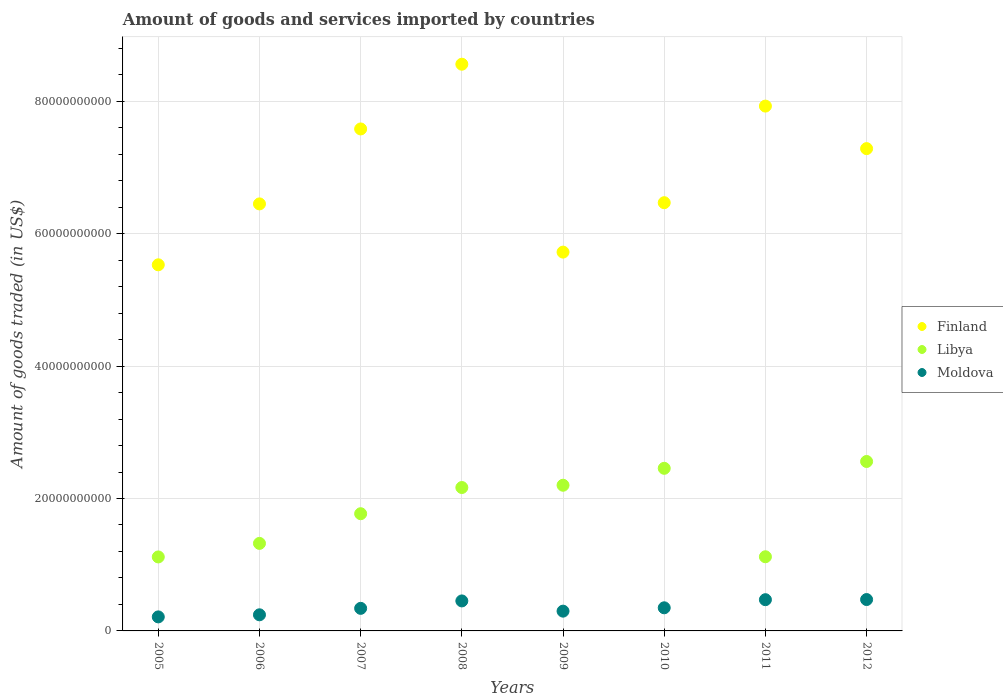How many different coloured dotlines are there?
Offer a terse response. 3. What is the total amount of goods and services imported in Libya in 2011?
Provide a succinct answer. 1.12e+1. Across all years, what is the maximum total amount of goods and services imported in Finland?
Provide a short and direct response. 8.56e+1. Across all years, what is the minimum total amount of goods and services imported in Moldova?
Your answer should be very brief. 2.12e+09. In which year was the total amount of goods and services imported in Libya maximum?
Give a very brief answer. 2012. What is the total total amount of goods and services imported in Finland in the graph?
Your response must be concise. 5.55e+11. What is the difference between the total amount of goods and services imported in Libya in 2005 and that in 2006?
Your answer should be compact. -2.04e+09. What is the difference between the total amount of goods and services imported in Finland in 2006 and the total amount of goods and services imported in Libya in 2005?
Ensure brevity in your answer.  5.33e+1. What is the average total amount of goods and services imported in Finland per year?
Offer a very short reply. 6.94e+1. In the year 2005, what is the difference between the total amount of goods and services imported in Libya and total amount of goods and services imported in Moldova?
Provide a short and direct response. 9.06e+09. What is the ratio of the total amount of goods and services imported in Finland in 2007 to that in 2009?
Provide a succinct answer. 1.33. Is the total amount of goods and services imported in Moldova in 2008 less than that in 2012?
Offer a terse response. Yes. What is the difference between the highest and the second highest total amount of goods and services imported in Libya?
Offer a very short reply. 1.03e+09. What is the difference between the highest and the lowest total amount of goods and services imported in Libya?
Provide a succinct answer. 1.44e+1. In how many years, is the total amount of goods and services imported in Moldova greater than the average total amount of goods and services imported in Moldova taken over all years?
Provide a succinct answer. 3. Is it the case that in every year, the sum of the total amount of goods and services imported in Libya and total amount of goods and services imported in Finland  is greater than the total amount of goods and services imported in Moldova?
Your answer should be compact. Yes. Does the total amount of goods and services imported in Libya monotonically increase over the years?
Give a very brief answer. No. Is the total amount of goods and services imported in Libya strictly greater than the total amount of goods and services imported in Finland over the years?
Keep it short and to the point. No. Is the total amount of goods and services imported in Libya strictly less than the total amount of goods and services imported in Moldova over the years?
Your answer should be compact. No. How many dotlines are there?
Give a very brief answer. 3. What is the difference between two consecutive major ticks on the Y-axis?
Make the answer very short. 2.00e+1. What is the title of the graph?
Ensure brevity in your answer.  Amount of goods and services imported by countries. Does "Kiribati" appear as one of the legend labels in the graph?
Ensure brevity in your answer.  No. What is the label or title of the X-axis?
Your response must be concise. Years. What is the label or title of the Y-axis?
Your response must be concise. Amount of goods traded (in US$). What is the Amount of goods traded (in US$) of Finland in 2005?
Ensure brevity in your answer.  5.53e+1. What is the Amount of goods traded (in US$) of Libya in 2005?
Provide a succinct answer. 1.12e+1. What is the Amount of goods traded (in US$) of Moldova in 2005?
Make the answer very short. 2.12e+09. What is the Amount of goods traded (in US$) of Finland in 2006?
Give a very brief answer. 6.45e+1. What is the Amount of goods traded (in US$) of Libya in 2006?
Your answer should be very brief. 1.32e+1. What is the Amount of goods traded (in US$) in Moldova in 2006?
Provide a short and direct response. 2.43e+09. What is the Amount of goods traded (in US$) of Finland in 2007?
Keep it short and to the point. 7.58e+1. What is the Amount of goods traded (in US$) of Libya in 2007?
Provide a short and direct response. 1.77e+1. What is the Amount of goods traded (in US$) of Moldova in 2007?
Make the answer very short. 3.41e+09. What is the Amount of goods traded (in US$) in Finland in 2008?
Ensure brevity in your answer.  8.56e+1. What is the Amount of goods traded (in US$) of Libya in 2008?
Your answer should be compact. 2.17e+1. What is the Amount of goods traded (in US$) in Moldova in 2008?
Your answer should be compact. 4.53e+09. What is the Amount of goods traded (in US$) of Finland in 2009?
Keep it short and to the point. 5.72e+1. What is the Amount of goods traded (in US$) of Libya in 2009?
Offer a very short reply. 2.20e+1. What is the Amount of goods traded (in US$) of Moldova in 2009?
Offer a very short reply. 2.99e+09. What is the Amount of goods traded (in US$) in Finland in 2010?
Your response must be concise. 6.47e+1. What is the Amount of goods traded (in US$) in Libya in 2010?
Provide a short and direct response. 2.46e+1. What is the Amount of goods traded (in US$) of Moldova in 2010?
Your answer should be very brief. 3.49e+09. What is the Amount of goods traded (in US$) of Finland in 2011?
Offer a terse response. 7.93e+1. What is the Amount of goods traded (in US$) in Libya in 2011?
Keep it short and to the point. 1.12e+1. What is the Amount of goods traded (in US$) in Moldova in 2011?
Your response must be concise. 4.72e+09. What is the Amount of goods traded (in US$) in Finland in 2012?
Give a very brief answer. 7.28e+1. What is the Amount of goods traded (in US$) of Libya in 2012?
Make the answer very short. 2.56e+1. What is the Amount of goods traded (in US$) in Moldova in 2012?
Offer a terse response. 4.74e+09. Across all years, what is the maximum Amount of goods traded (in US$) of Finland?
Keep it short and to the point. 8.56e+1. Across all years, what is the maximum Amount of goods traded (in US$) in Libya?
Offer a very short reply. 2.56e+1. Across all years, what is the maximum Amount of goods traded (in US$) in Moldova?
Provide a succinct answer. 4.74e+09. Across all years, what is the minimum Amount of goods traded (in US$) in Finland?
Provide a succinct answer. 5.53e+1. Across all years, what is the minimum Amount of goods traded (in US$) in Libya?
Ensure brevity in your answer.  1.12e+1. Across all years, what is the minimum Amount of goods traded (in US$) of Moldova?
Offer a very short reply. 2.12e+09. What is the total Amount of goods traded (in US$) of Finland in the graph?
Your answer should be compact. 5.55e+11. What is the total Amount of goods traded (in US$) in Libya in the graph?
Make the answer very short. 1.47e+11. What is the total Amount of goods traded (in US$) in Moldova in the graph?
Your answer should be compact. 2.84e+1. What is the difference between the Amount of goods traded (in US$) of Finland in 2005 and that in 2006?
Your response must be concise. -9.20e+09. What is the difference between the Amount of goods traded (in US$) in Libya in 2005 and that in 2006?
Your answer should be very brief. -2.04e+09. What is the difference between the Amount of goods traded (in US$) in Moldova in 2005 and that in 2006?
Ensure brevity in your answer.  -3.15e+08. What is the difference between the Amount of goods traded (in US$) of Finland in 2005 and that in 2007?
Your response must be concise. -2.05e+1. What is the difference between the Amount of goods traded (in US$) in Libya in 2005 and that in 2007?
Make the answer very short. -6.53e+09. What is the difference between the Amount of goods traded (in US$) in Moldova in 2005 and that in 2007?
Offer a very short reply. -1.29e+09. What is the difference between the Amount of goods traded (in US$) in Finland in 2005 and that in 2008?
Offer a terse response. -3.03e+1. What is the difference between the Amount of goods traded (in US$) of Libya in 2005 and that in 2008?
Your answer should be compact. -1.05e+1. What is the difference between the Amount of goods traded (in US$) of Moldova in 2005 and that in 2008?
Your answer should be very brief. -2.41e+09. What is the difference between the Amount of goods traded (in US$) in Finland in 2005 and that in 2009?
Ensure brevity in your answer.  -1.92e+09. What is the difference between the Amount of goods traded (in US$) in Libya in 2005 and that in 2009?
Provide a succinct answer. -1.08e+1. What is the difference between the Amount of goods traded (in US$) of Moldova in 2005 and that in 2009?
Offer a terse response. -8.68e+08. What is the difference between the Amount of goods traded (in US$) in Finland in 2005 and that in 2010?
Your answer should be compact. -9.38e+09. What is the difference between the Amount of goods traded (in US$) in Libya in 2005 and that in 2010?
Ensure brevity in your answer.  -1.34e+1. What is the difference between the Amount of goods traded (in US$) in Moldova in 2005 and that in 2010?
Give a very brief answer. -1.37e+09. What is the difference between the Amount of goods traded (in US$) of Finland in 2005 and that in 2011?
Your response must be concise. -2.40e+1. What is the difference between the Amount of goods traded (in US$) of Libya in 2005 and that in 2011?
Your answer should be compact. -2.60e+07. What is the difference between the Amount of goods traded (in US$) in Moldova in 2005 and that in 2011?
Give a very brief answer. -2.60e+09. What is the difference between the Amount of goods traded (in US$) in Finland in 2005 and that in 2012?
Your answer should be very brief. -1.75e+1. What is the difference between the Amount of goods traded (in US$) in Libya in 2005 and that in 2012?
Provide a succinct answer. -1.44e+1. What is the difference between the Amount of goods traded (in US$) in Moldova in 2005 and that in 2012?
Keep it short and to the point. -2.62e+09. What is the difference between the Amount of goods traded (in US$) in Finland in 2006 and that in 2007?
Your answer should be compact. -1.13e+1. What is the difference between the Amount of goods traded (in US$) in Libya in 2006 and that in 2007?
Provide a succinct answer. -4.48e+09. What is the difference between the Amount of goods traded (in US$) in Moldova in 2006 and that in 2007?
Ensure brevity in your answer.  -9.75e+08. What is the difference between the Amount of goods traded (in US$) in Finland in 2006 and that in 2008?
Give a very brief answer. -2.11e+1. What is the difference between the Amount of goods traded (in US$) of Libya in 2006 and that in 2008?
Your answer should be compact. -8.44e+09. What is the difference between the Amount of goods traded (in US$) in Moldova in 2006 and that in 2008?
Keep it short and to the point. -2.10e+09. What is the difference between the Amount of goods traded (in US$) in Finland in 2006 and that in 2009?
Provide a short and direct response. 7.28e+09. What is the difference between the Amount of goods traded (in US$) in Libya in 2006 and that in 2009?
Offer a very short reply. -8.78e+09. What is the difference between the Amount of goods traded (in US$) in Moldova in 2006 and that in 2009?
Give a very brief answer. -5.53e+08. What is the difference between the Amount of goods traded (in US$) of Finland in 2006 and that in 2010?
Keep it short and to the point. -1.81e+08. What is the difference between the Amount of goods traded (in US$) in Libya in 2006 and that in 2010?
Your answer should be very brief. -1.13e+1. What is the difference between the Amount of goods traded (in US$) of Moldova in 2006 and that in 2010?
Your response must be concise. -1.06e+09. What is the difference between the Amount of goods traded (in US$) of Finland in 2006 and that in 2011?
Give a very brief answer. -1.48e+1. What is the difference between the Amount of goods traded (in US$) of Libya in 2006 and that in 2011?
Ensure brevity in your answer.  2.02e+09. What is the difference between the Amount of goods traded (in US$) in Moldova in 2006 and that in 2011?
Offer a terse response. -2.28e+09. What is the difference between the Amount of goods traded (in US$) in Finland in 2006 and that in 2012?
Your answer should be compact. -8.35e+09. What is the difference between the Amount of goods traded (in US$) in Libya in 2006 and that in 2012?
Keep it short and to the point. -1.24e+1. What is the difference between the Amount of goods traded (in US$) of Moldova in 2006 and that in 2012?
Provide a succinct answer. -2.30e+09. What is the difference between the Amount of goods traded (in US$) in Finland in 2007 and that in 2008?
Your answer should be compact. -9.78e+09. What is the difference between the Amount of goods traded (in US$) in Libya in 2007 and that in 2008?
Your response must be concise. -3.96e+09. What is the difference between the Amount of goods traded (in US$) in Moldova in 2007 and that in 2008?
Your response must be concise. -1.12e+09. What is the difference between the Amount of goods traded (in US$) in Finland in 2007 and that in 2009?
Keep it short and to the point. 1.86e+1. What is the difference between the Amount of goods traded (in US$) of Libya in 2007 and that in 2009?
Provide a succinct answer. -4.30e+09. What is the difference between the Amount of goods traded (in US$) in Moldova in 2007 and that in 2009?
Make the answer very short. 4.22e+08. What is the difference between the Amount of goods traded (in US$) in Finland in 2007 and that in 2010?
Offer a terse response. 1.11e+1. What is the difference between the Amount of goods traded (in US$) of Libya in 2007 and that in 2010?
Your response must be concise. -6.86e+09. What is the difference between the Amount of goods traded (in US$) of Moldova in 2007 and that in 2010?
Make the answer very short. -8.27e+07. What is the difference between the Amount of goods traded (in US$) in Finland in 2007 and that in 2011?
Offer a terse response. -3.45e+09. What is the difference between the Amount of goods traded (in US$) in Libya in 2007 and that in 2011?
Your answer should be very brief. 6.50e+09. What is the difference between the Amount of goods traded (in US$) in Moldova in 2007 and that in 2011?
Offer a terse response. -1.31e+09. What is the difference between the Amount of goods traded (in US$) in Finland in 2007 and that in 2012?
Keep it short and to the point. 2.97e+09. What is the difference between the Amount of goods traded (in US$) of Libya in 2007 and that in 2012?
Your response must be concise. -7.89e+09. What is the difference between the Amount of goods traded (in US$) in Moldova in 2007 and that in 2012?
Offer a terse response. -1.33e+09. What is the difference between the Amount of goods traded (in US$) of Finland in 2008 and that in 2009?
Make the answer very short. 2.84e+1. What is the difference between the Amount of goods traded (in US$) of Libya in 2008 and that in 2009?
Provide a succinct answer. -3.44e+08. What is the difference between the Amount of goods traded (in US$) in Moldova in 2008 and that in 2009?
Keep it short and to the point. 1.54e+09. What is the difference between the Amount of goods traded (in US$) of Finland in 2008 and that in 2010?
Provide a short and direct response. 2.09e+1. What is the difference between the Amount of goods traded (in US$) in Libya in 2008 and that in 2010?
Your answer should be compact. -2.90e+09. What is the difference between the Amount of goods traded (in US$) of Moldova in 2008 and that in 2010?
Keep it short and to the point. 1.04e+09. What is the difference between the Amount of goods traded (in US$) of Finland in 2008 and that in 2011?
Your answer should be compact. 6.33e+09. What is the difference between the Amount of goods traded (in US$) of Libya in 2008 and that in 2011?
Offer a terse response. 1.05e+1. What is the difference between the Amount of goods traded (in US$) in Moldova in 2008 and that in 2011?
Keep it short and to the point. -1.86e+08. What is the difference between the Amount of goods traded (in US$) in Finland in 2008 and that in 2012?
Keep it short and to the point. 1.27e+1. What is the difference between the Amount of goods traded (in US$) of Libya in 2008 and that in 2012?
Your answer should be very brief. -3.93e+09. What is the difference between the Amount of goods traded (in US$) in Moldova in 2008 and that in 2012?
Your response must be concise. -2.09e+08. What is the difference between the Amount of goods traded (in US$) of Finland in 2009 and that in 2010?
Offer a very short reply. -7.46e+09. What is the difference between the Amount of goods traded (in US$) of Libya in 2009 and that in 2010?
Provide a succinct answer. -2.56e+09. What is the difference between the Amount of goods traded (in US$) in Moldova in 2009 and that in 2010?
Provide a short and direct response. -5.05e+08. What is the difference between the Amount of goods traded (in US$) in Finland in 2009 and that in 2011?
Give a very brief answer. -2.21e+1. What is the difference between the Amount of goods traded (in US$) of Libya in 2009 and that in 2011?
Provide a short and direct response. 1.08e+1. What is the difference between the Amount of goods traded (in US$) of Moldova in 2009 and that in 2011?
Your answer should be compact. -1.73e+09. What is the difference between the Amount of goods traded (in US$) of Finland in 2009 and that in 2012?
Your answer should be very brief. -1.56e+1. What is the difference between the Amount of goods traded (in US$) in Libya in 2009 and that in 2012?
Make the answer very short. -3.59e+09. What is the difference between the Amount of goods traded (in US$) in Moldova in 2009 and that in 2012?
Make the answer very short. -1.75e+09. What is the difference between the Amount of goods traded (in US$) of Finland in 2010 and that in 2011?
Offer a very short reply. -1.46e+1. What is the difference between the Amount of goods traded (in US$) in Libya in 2010 and that in 2011?
Offer a very short reply. 1.34e+1. What is the difference between the Amount of goods traded (in US$) in Moldova in 2010 and that in 2011?
Your response must be concise. -1.22e+09. What is the difference between the Amount of goods traded (in US$) of Finland in 2010 and that in 2012?
Give a very brief answer. -8.17e+09. What is the difference between the Amount of goods traded (in US$) of Libya in 2010 and that in 2012?
Give a very brief answer. -1.03e+09. What is the difference between the Amount of goods traded (in US$) in Moldova in 2010 and that in 2012?
Keep it short and to the point. -1.25e+09. What is the difference between the Amount of goods traded (in US$) of Finland in 2011 and that in 2012?
Make the answer very short. 6.42e+09. What is the difference between the Amount of goods traded (in US$) in Libya in 2011 and that in 2012?
Offer a very short reply. -1.44e+1. What is the difference between the Amount of goods traded (in US$) in Moldova in 2011 and that in 2012?
Ensure brevity in your answer.  -2.27e+07. What is the difference between the Amount of goods traded (in US$) in Finland in 2005 and the Amount of goods traded (in US$) in Libya in 2006?
Keep it short and to the point. 4.21e+1. What is the difference between the Amount of goods traded (in US$) of Finland in 2005 and the Amount of goods traded (in US$) of Moldova in 2006?
Keep it short and to the point. 5.29e+1. What is the difference between the Amount of goods traded (in US$) of Libya in 2005 and the Amount of goods traded (in US$) of Moldova in 2006?
Your answer should be compact. 8.74e+09. What is the difference between the Amount of goods traded (in US$) in Finland in 2005 and the Amount of goods traded (in US$) in Libya in 2007?
Give a very brief answer. 3.76e+1. What is the difference between the Amount of goods traded (in US$) of Finland in 2005 and the Amount of goods traded (in US$) of Moldova in 2007?
Provide a succinct answer. 5.19e+1. What is the difference between the Amount of goods traded (in US$) in Libya in 2005 and the Amount of goods traded (in US$) in Moldova in 2007?
Offer a very short reply. 7.77e+09. What is the difference between the Amount of goods traded (in US$) of Finland in 2005 and the Amount of goods traded (in US$) of Libya in 2008?
Your answer should be compact. 3.36e+1. What is the difference between the Amount of goods traded (in US$) in Finland in 2005 and the Amount of goods traded (in US$) in Moldova in 2008?
Offer a very short reply. 5.08e+1. What is the difference between the Amount of goods traded (in US$) in Libya in 2005 and the Amount of goods traded (in US$) in Moldova in 2008?
Give a very brief answer. 6.64e+09. What is the difference between the Amount of goods traded (in US$) in Finland in 2005 and the Amount of goods traded (in US$) in Libya in 2009?
Offer a terse response. 3.33e+1. What is the difference between the Amount of goods traded (in US$) in Finland in 2005 and the Amount of goods traded (in US$) in Moldova in 2009?
Your response must be concise. 5.23e+1. What is the difference between the Amount of goods traded (in US$) in Libya in 2005 and the Amount of goods traded (in US$) in Moldova in 2009?
Your answer should be compact. 8.19e+09. What is the difference between the Amount of goods traded (in US$) in Finland in 2005 and the Amount of goods traded (in US$) in Libya in 2010?
Your answer should be compact. 3.07e+1. What is the difference between the Amount of goods traded (in US$) in Finland in 2005 and the Amount of goods traded (in US$) in Moldova in 2010?
Your response must be concise. 5.18e+1. What is the difference between the Amount of goods traded (in US$) of Libya in 2005 and the Amount of goods traded (in US$) of Moldova in 2010?
Give a very brief answer. 7.68e+09. What is the difference between the Amount of goods traded (in US$) of Finland in 2005 and the Amount of goods traded (in US$) of Libya in 2011?
Your response must be concise. 4.41e+1. What is the difference between the Amount of goods traded (in US$) in Finland in 2005 and the Amount of goods traded (in US$) in Moldova in 2011?
Offer a terse response. 5.06e+1. What is the difference between the Amount of goods traded (in US$) of Libya in 2005 and the Amount of goods traded (in US$) of Moldova in 2011?
Your answer should be compact. 6.46e+09. What is the difference between the Amount of goods traded (in US$) of Finland in 2005 and the Amount of goods traded (in US$) of Libya in 2012?
Offer a very short reply. 2.97e+1. What is the difference between the Amount of goods traded (in US$) in Finland in 2005 and the Amount of goods traded (in US$) in Moldova in 2012?
Keep it short and to the point. 5.06e+1. What is the difference between the Amount of goods traded (in US$) of Libya in 2005 and the Amount of goods traded (in US$) of Moldova in 2012?
Offer a terse response. 6.44e+09. What is the difference between the Amount of goods traded (in US$) of Finland in 2006 and the Amount of goods traded (in US$) of Libya in 2007?
Offer a very short reply. 4.68e+1. What is the difference between the Amount of goods traded (in US$) of Finland in 2006 and the Amount of goods traded (in US$) of Moldova in 2007?
Make the answer very short. 6.11e+1. What is the difference between the Amount of goods traded (in US$) of Libya in 2006 and the Amount of goods traded (in US$) of Moldova in 2007?
Ensure brevity in your answer.  9.81e+09. What is the difference between the Amount of goods traded (in US$) in Finland in 2006 and the Amount of goods traded (in US$) in Libya in 2008?
Offer a terse response. 4.28e+1. What is the difference between the Amount of goods traded (in US$) in Finland in 2006 and the Amount of goods traded (in US$) in Moldova in 2008?
Provide a succinct answer. 6.00e+1. What is the difference between the Amount of goods traded (in US$) in Libya in 2006 and the Amount of goods traded (in US$) in Moldova in 2008?
Provide a short and direct response. 8.69e+09. What is the difference between the Amount of goods traded (in US$) of Finland in 2006 and the Amount of goods traded (in US$) of Libya in 2009?
Offer a very short reply. 4.25e+1. What is the difference between the Amount of goods traded (in US$) in Finland in 2006 and the Amount of goods traded (in US$) in Moldova in 2009?
Your answer should be compact. 6.15e+1. What is the difference between the Amount of goods traded (in US$) of Libya in 2006 and the Amount of goods traded (in US$) of Moldova in 2009?
Make the answer very short. 1.02e+1. What is the difference between the Amount of goods traded (in US$) in Finland in 2006 and the Amount of goods traded (in US$) in Libya in 2010?
Your response must be concise. 3.99e+1. What is the difference between the Amount of goods traded (in US$) in Finland in 2006 and the Amount of goods traded (in US$) in Moldova in 2010?
Your response must be concise. 6.10e+1. What is the difference between the Amount of goods traded (in US$) in Libya in 2006 and the Amount of goods traded (in US$) in Moldova in 2010?
Keep it short and to the point. 9.73e+09. What is the difference between the Amount of goods traded (in US$) in Finland in 2006 and the Amount of goods traded (in US$) in Libya in 2011?
Make the answer very short. 5.33e+1. What is the difference between the Amount of goods traded (in US$) in Finland in 2006 and the Amount of goods traded (in US$) in Moldova in 2011?
Keep it short and to the point. 5.98e+1. What is the difference between the Amount of goods traded (in US$) of Libya in 2006 and the Amount of goods traded (in US$) of Moldova in 2011?
Provide a succinct answer. 8.50e+09. What is the difference between the Amount of goods traded (in US$) of Finland in 2006 and the Amount of goods traded (in US$) of Libya in 2012?
Keep it short and to the point. 3.89e+1. What is the difference between the Amount of goods traded (in US$) in Finland in 2006 and the Amount of goods traded (in US$) in Moldova in 2012?
Make the answer very short. 5.98e+1. What is the difference between the Amount of goods traded (in US$) of Libya in 2006 and the Amount of goods traded (in US$) of Moldova in 2012?
Provide a succinct answer. 8.48e+09. What is the difference between the Amount of goods traded (in US$) in Finland in 2007 and the Amount of goods traded (in US$) in Libya in 2008?
Ensure brevity in your answer.  5.42e+1. What is the difference between the Amount of goods traded (in US$) of Finland in 2007 and the Amount of goods traded (in US$) of Moldova in 2008?
Your answer should be very brief. 7.13e+1. What is the difference between the Amount of goods traded (in US$) of Libya in 2007 and the Amount of goods traded (in US$) of Moldova in 2008?
Your answer should be very brief. 1.32e+1. What is the difference between the Amount of goods traded (in US$) of Finland in 2007 and the Amount of goods traded (in US$) of Libya in 2009?
Provide a succinct answer. 5.38e+1. What is the difference between the Amount of goods traded (in US$) in Finland in 2007 and the Amount of goods traded (in US$) in Moldova in 2009?
Ensure brevity in your answer.  7.28e+1. What is the difference between the Amount of goods traded (in US$) of Libya in 2007 and the Amount of goods traded (in US$) of Moldova in 2009?
Ensure brevity in your answer.  1.47e+1. What is the difference between the Amount of goods traded (in US$) of Finland in 2007 and the Amount of goods traded (in US$) of Libya in 2010?
Make the answer very short. 5.13e+1. What is the difference between the Amount of goods traded (in US$) in Finland in 2007 and the Amount of goods traded (in US$) in Moldova in 2010?
Your answer should be compact. 7.23e+1. What is the difference between the Amount of goods traded (in US$) in Libya in 2007 and the Amount of goods traded (in US$) in Moldova in 2010?
Provide a short and direct response. 1.42e+1. What is the difference between the Amount of goods traded (in US$) of Finland in 2007 and the Amount of goods traded (in US$) of Libya in 2011?
Your answer should be very brief. 6.46e+1. What is the difference between the Amount of goods traded (in US$) of Finland in 2007 and the Amount of goods traded (in US$) of Moldova in 2011?
Give a very brief answer. 7.11e+1. What is the difference between the Amount of goods traded (in US$) of Libya in 2007 and the Amount of goods traded (in US$) of Moldova in 2011?
Keep it short and to the point. 1.30e+1. What is the difference between the Amount of goods traded (in US$) of Finland in 2007 and the Amount of goods traded (in US$) of Libya in 2012?
Provide a succinct answer. 5.02e+1. What is the difference between the Amount of goods traded (in US$) in Finland in 2007 and the Amount of goods traded (in US$) in Moldova in 2012?
Your answer should be very brief. 7.11e+1. What is the difference between the Amount of goods traded (in US$) of Libya in 2007 and the Amount of goods traded (in US$) of Moldova in 2012?
Provide a short and direct response. 1.30e+1. What is the difference between the Amount of goods traded (in US$) in Finland in 2008 and the Amount of goods traded (in US$) in Libya in 2009?
Give a very brief answer. 6.36e+1. What is the difference between the Amount of goods traded (in US$) of Finland in 2008 and the Amount of goods traded (in US$) of Moldova in 2009?
Keep it short and to the point. 8.26e+1. What is the difference between the Amount of goods traded (in US$) in Libya in 2008 and the Amount of goods traded (in US$) in Moldova in 2009?
Provide a succinct answer. 1.87e+1. What is the difference between the Amount of goods traded (in US$) in Finland in 2008 and the Amount of goods traded (in US$) in Libya in 2010?
Offer a very short reply. 6.10e+1. What is the difference between the Amount of goods traded (in US$) of Finland in 2008 and the Amount of goods traded (in US$) of Moldova in 2010?
Offer a very short reply. 8.21e+1. What is the difference between the Amount of goods traded (in US$) in Libya in 2008 and the Amount of goods traded (in US$) in Moldova in 2010?
Make the answer very short. 1.82e+1. What is the difference between the Amount of goods traded (in US$) in Finland in 2008 and the Amount of goods traded (in US$) in Libya in 2011?
Your answer should be very brief. 7.44e+1. What is the difference between the Amount of goods traded (in US$) in Finland in 2008 and the Amount of goods traded (in US$) in Moldova in 2011?
Give a very brief answer. 8.09e+1. What is the difference between the Amount of goods traded (in US$) in Libya in 2008 and the Amount of goods traded (in US$) in Moldova in 2011?
Make the answer very short. 1.69e+1. What is the difference between the Amount of goods traded (in US$) of Finland in 2008 and the Amount of goods traded (in US$) of Libya in 2012?
Make the answer very short. 6.00e+1. What is the difference between the Amount of goods traded (in US$) in Finland in 2008 and the Amount of goods traded (in US$) in Moldova in 2012?
Make the answer very short. 8.09e+1. What is the difference between the Amount of goods traded (in US$) in Libya in 2008 and the Amount of goods traded (in US$) in Moldova in 2012?
Your answer should be compact. 1.69e+1. What is the difference between the Amount of goods traded (in US$) of Finland in 2009 and the Amount of goods traded (in US$) of Libya in 2010?
Your response must be concise. 3.27e+1. What is the difference between the Amount of goods traded (in US$) in Finland in 2009 and the Amount of goods traded (in US$) in Moldova in 2010?
Provide a succinct answer. 5.37e+1. What is the difference between the Amount of goods traded (in US$) of Libya in 2009 and the Amount of goods traded (in US$) of Moldova in 2010?
Your answer should be very brief. 1.85e+1. What is the difference between the Amount of goods traded (in US$) of Finland in 2009 and the Amount of goods traded (in US$) of Libya in 2011?
Make the answer very short. 4.60e+1. What is the difference between the Amount of goods traded (in US$) of Finland in 2009 and the Amount of goods traded (in US$) of Moldova in 2011?
Offer a terse response. 5.25e+1. What is the difference between the Amount of goods traded (in US$) in Libya in 2009 and the Amount of goods traded (in US$) in Moldova in 2011?
Give a very brief answer. 1.73e+1. What is the difference between the Amount of goods traded (in US$) of Finland in 2009 and the Amount of goods traded (in US$) of Libya in 2012?
Provide a short and direct response. 3.16e+1. What is the difference between the Amount of goods traded (in US$) of Finland in 2009 and the Amount of goods traded (in US$) of Moldova in 2012?
Provide a short and direct response. 5.25e+1. What is the difference between the Amount of goods traded (in US$) of Libya in 2009 and the Amount of goods traded (in US$) of Moldova in 2012?
Offer a very short reply. 1.73e+1. What is the difference between the Amount of goods traded (in US$) of Finland in 2010 and the Amount of goods traded (in US$) of Libya in 2011?
Provide a short and direct response. 5.35e+1. What is the difference between the Amount of goods traded (in US$) of Finland in 2010 and the Amount of goods traded (in US$) of Moldova in 2011?
Your response must be concise. 6.00e+1. What is the difference between the Amount of goods traded (in US$) in Libya in 2010 and the Amount of goods traded (in US$) in Moldova in 2011?
Your response must be concise. 1.98e+1. What is the difference between the Amount of goods traded (in US$) in Finland in 2010 and the Amount of goods traded (in US$) in Libya in 2012?
Your response must be concise. 3.91e+1. What is the difference between the Amount of goods traded (in US$) of Finland in 2010 and the Amount of goods traded (in US$) of Moldova in 2012?
Offer a very short reply. 5.99e+1. What is the difference between the Amount of goods traded (in US$) of Libya in 2010 and the Amount of goods traded (in US$) of Moldova in 2012?
Offer a very short reply. 1.98e+1. What is the difference between the Amount of goods traded (in US$) in Finland in 2011 and the Amount of goods traded (in US$) in Libya in 2012?
Your response must be concise. 5.37e+1. What is the difference between the Amount of goods traded (in US$) of Finland in 2011 and the Amount of goods traded (in US$) of Moldova in 2012?
Keep it short and to the point. 7.45e+1. What is the difference between the Amount of goods traded (in US$) in Libya in 2011 and the Amount of goods traded (in US$) in Moldova in 2012?
Keep it short and to the point. 6.46e+09. What is the average Amount of goods traded (in US$) of Finland per year?
Make the answer very short. 6.94e+1. What is the average Amount of goods traded (in US$) of Libya per year?
Keep it short and to the point. 1.84e+1. What is the average Amount of goods traded (in US$) of Moldova per year?
Offer a very short reply. 3.55e+09. In the year 2005, what is the difference between the Amount of goods traded (in US$) of Finland and Amount of goods traded (in US$) of Libya?
Offer a very short reply. 4.41e+1. In the year 2005, what is the difference between the Amount of goods traded (in US$) of Finland and Amount of goods traded (in US$) of Moldova?
Give a very brief answer. 5.32e+1. In the year 2005, what is the difference between the Amount of goods traded (in US$) of Libya and Amount of goods traded (in US$) of Moldova?
Offer a very short reply. 9.06e+09. In the year 2006, what is the difference between the Amount of goods traded (in US$) in Finland and Amount of goods traded (in US$) in Libya?
Make the answer very short. 5.13e+1. In the year 2006, what is the difference between the Amount of goods traded (in US$) in Finland and Amount of goods traded (in US$) in Moldova?
Make the answer very short. 6.21e+1. In the year 2006, what is the difference between the Amount of goods traded (in US$) in Libya and Amount of goods traded (in US$) in Moldova?
Provide a succinct answer. 1.08e+1. In the year 2007, what is the difference between the Amount of goods traded (in US$) of Finland and Amount of goods traded (in US$) of Libya?
Your answer should be compact. 5.81e+1. In the year 2007, what is the difference between the Amount of goods traded (in US$) in Finland and Amount of goods traded (in US$) in Moldova?
Your answer should be compact. 7.24e+1. In the year 2007, what is the difference between the Amount of goods traded (in US$) in Libya and Amount of goods traded (in US$) in Moldova?
Give a very brief answer. 1.43e+1. In the year 2008, what is the difference between the Amount of goods traded (in US$) in Finland and Amount of goods traded (in US$) in Libya?
Provide a short and direct response. 6.39e+1. In the year 2008, what is the difference between the Amount of goods traded (in US$) of Finland and Amount of goods traded (in US$) of Moldova?
Provide a short and direct response. 8.11e+1. In the year 2008, what is the difference between the Amount of goods traded (in US$) of Libya and Amount of goods traded (in US$) of Moldova?
Make the answer very short. 1.71e+1. In the year 2009, what is the difference between the Amount of goods traded (in US$) in Finland and Amount of goods traded (in US$) in Libya?
Ensure brevity in your answer.  3.52e+1. In the year 2009, what is the difference between the Amount of goods traded (in US$) of Finland and Amount of goods traded (in US$) of Moldova?
Keep it short and to the point. 5.42e+1. In the year 2009, what is the difference between the Amount of goods traded (in US$) of Libya and Amount of goods traded (in US$) of Moldova?
Offer a terse response. 1.90e+1. In the year 2010, what is the difference between the Amount of goods traded (in US$) of Finland and Amount of goods traded (in US$) of Libya?
Make the answer very short. 4.01e+1. In the year 2010, what is the difference between the Amount of goods traded (in US$) in Finland and Amount of goods traded (in US$) in Moldova?
Provide a short and direct response. 6.12e+1. In the year 2010, what is the difference between the Amount of goods traded (in US$) of Libya and Amount of goods traded (in US$) of Moldova?
Your answer should be compact. 2.11e+1. In the year 2011, what is the difference between the Amount of goods traded (in US$) in Finland and Amount of goods traded (in US$) in Libya?
Provide a short and direct response. 6.81e+1. In the year 2011, what is the difference between the Amount of goods traded (in US$) of Finland and Amount of goods traded (in US$) of Moldova?
Your answer should be compact. 7.45e+1. In the year 2011, what is the difference between the Amount of goods traded (in US$) in Libya and Amount of goods traded (in US$) in Moldova?
Offer a very short reply. 6.48e+09. In the year 2012, what is the difference between the Amount of goods traded (in US$) of Finland and Amount of goods traded (in US$) of Libya?
Keep it short and to the point. 4.73e+1. In the year 2012, what is the difference between the Amount of goods traded (in US$) in Finland and Amount of goods traded (in US$) in Moldova?
Your response must be concise. 6.81e+1. In the year 2012, what is the difference between the Amount of goods traded (in US$) in Libya and Amount of goods traded (in US$) in Moldova?
Make the answer very short. 2.09e+1. What is the ratio of the Amount of goods traded (in US$) in Finland in 2005 to that in 2006?
Make the answer very short. 0.86. What is the ratio of the Amount of goods traded (in US$) in Libya in 2005 to that in 2006?
Give a very brief answer. 0.85. What is the ratio of the Amount of goods traded (in US$) of Moldova in 2005 to that in 2006?
Ensure brevity in your answer.  0.87. What is the ratio of the Amount of goods traded (in US$) in Finland in 2005 to that in 2007?
Give a very brief answer. 0.73. What is the ratio of the Amount of goods traded (in US$) in Libya in 2005 to that in 2007?
Provide a succinct answer. 0.63. What is the ratio of the Amount of goods traded (in US$) of Moldova in 2005 to that in 2007?
Provide a short and direct response. 0.62. What is the ratio of the Amount of goods traded (in US$) of Finland in 2005 to that in 2008?
Provide a succinct answer. 0.65. What is the ratio of the Amount of goods traded (in US$) of Libya in 2005 to that in 2008?
Give a very brief answer. 0.52. What is the ratio of the Amount of goods traded (in US$) in Moldova in 2005 to that in 2008?
Offer a very short reply. 0.47. What is the ratio of the Amount of goods traded (in US$) of Finland in 2005 to that in 2009?
Keep it short and to the point. 0.97. What is the ratio of the Amount of goods traded (in US$) in Libya in 2005 to that in 2009?
Offer a very short reply. 0.51. What is the ratio of the Amount of goods traded (in US$) in Moldova in 2005 to that in 2009?
Give a very brief answer. 0.71. What is the ratio of the Amount of goods traded (in US$) in Finland in 2005 to that in 2010?
Offer a terse response. 0.85. What is the ratio of the Amount of goods traded (in US$) in Libya in 2005 to that in 2010?
Your answer should be compact. 0.46. What is the ratio of the Amount of goods traded (in US$) in Moldova in 2005 to that in 2010?
Your answer should be compact. 0.61. What is the ratio of the Amount of goods traded (in US$) in Finland in 2005 to that in 2011?
Offer a terse response. 0.7. What is the ratio of the Amount of goods traded (in US$) in Libya in 2005 to that in 2011?
Keep it short and to the point. 1. What is the ratio of the Amount of goods traded (in US$) in Moldova in 2005 to that in 2011?
Ensure brevity in your answer.  0.45. What is the ratio of the Amount of goods traded (in US$) in Finland in 2005 to that in 2012?
Ensure brevity in your answer.  0.76. What is the ratio of the Amount of goods traded (in US$) in Libya in 2005 to that in 2012?
Make the answer very short. 0.44. What is the ratio of the Amount of goods traded (in US$) of Moldova in 2005 to that in 2012?
Offer a terse response. 0.45. What is the ratio of the Amount of goods traded (in US$) of Finland in 2006 to that in 2007?
Your response must be concise. 0.85. What is the ratio of the Amount of goods traded (in US$) in Libya in 2006 to that in 2007?
Provide a short and direct response. 0.75. What is the ratio of the Amount of goods traded (in US$) of Moldova in 2006 to that in 2007?
Keep it short and to the point. 0.71. What is the ratio of the Amount of goods traded (in US$) of Finland in 2006 to that in 2008?
Provide a succinct answer. 0.75. What is the ratio of the Amount of goods traded (in US$) of Libya in 2006 to that in 2008?
Your answer should be very brief. 0.61. What is the ratio of the Amount of goods traded (in US$) in Moldova in 2006 to that in 2008?
Provide a succinct answer. 0.54. What is the ratio of the Amount of goods traded (in US$) of Finland in 2006 to that in 2009?
Ensure brevity in your answer.  1.13. What is the ratio of the Amount of goods traded (in US$) in Libya in 2006 to that in 2009?
Provide a succinct answer. 0.6. What is the ratio of the Amount of goods traded (in US$) in Moldova in 2006 to that in 2009?
Offer a very short reply. 0.81. What is the ratio of the Amount of goods traded (in US$) of Libya in 2006 to that in 2010?
Your answer should be compact. 0.54. What is the ratio of the Amount of goods traded (in US$) in Moldova in 2006 to that in 2010?
Make the answer very short. 0.7. What is the ratio of the Amount of goods traded (in US$) of Finland in 2006 to that in 2011?
Ensure brevity in your answer.  0.81. What is the ratio of the Amount of goods traded (in US$) of Libya in 2006 to that in 2011?
Keep it short and to the point. 1.18. What is the ratio of the Amount of goods traded (in US$) of Moldova in 2006 to that in 2011?
Ensure brevity in your answer.  0.52. What is the ratio of the Amount of goods traded (in US$) in Finland in 2006 to that in 2012?
Provide a short and direct response. 0.89. What is the ratio of the Amount of goods traded (in US$) of Libya in 2006 to that in 2012?
Your response must be concise. 0.52. What is the ratio of the Amount of goods traded (in US$) in Moldova in 2006 to that in 2012?
Give a very brief answer. 0.51. What is the ratio of the Amount of goods traded (in US$) in Finland in 2007 to that in 2008?
Your answer should be very brief. 0.89. What is the ratio of the Amount of goods traded (in US$) in Libya in 2007 to that in 2008?
Keep it short and to the point. 0.82. What is the ratio of the Amount of goods traded (in US$) in Moldova in 2007 to that in 2008?
Your response must be concise. 0.75. What is the ratio of the Amount of goods traded (in US$) of Finland in 2007 to that in 2009?
Give a very brief answer. 1.33. What is the ratio of the Amount of goods traded (in US$) in Libya in 2007 to that in 2009?
Keep it short and to the point. 0.8. What is the ratio of the Amount of goods traded (in US$) in Moldova in 2007 to that in 2009?
Keep it short and to the point. 1.14. What is the ratio of the Amount of goods traded (in US$) of Finland in 2007 to that in 2010?
Make the answer very short. 1.17. What is the ratio of the Amount of goods traded (in US$) of Libya in 2007 to that in 2010?
Your answer should be compact. 0.72. What is the ratio of the Amount of goods traded (in US$) of Moldova in 2007 to that in 2010?
Offer a terse response. 0.98. What is the ratio of the Amount of goods traded (in US$) in Finland in 2007 to that in 2011?
Provide a short and direct response. 0.96. What is the ratio of the Amount of goods traded (in US$) of Libya in 2007 to that in 2011?
Keep it short and to the point. 1.58. What is the ratio of the Amount of goods traded (in US$) of Moldova in 2007 to that in 2011?
Your answer should be very brief. 0.72. What is the ratio of the Amount of goods traded (in US$) of Finland in 2007 to that in 2012?
Ensure brevity in your answer.  1.04. What is the ratio of the Amount of goods traded (in US$) in Libya in 2007 to that in 2012?
Keep it short and to the point. 0.69. What is the ratio of the Amount of goods traded (in US$) in Moldova in 2007 to that in 2012?
Provide a succinct answer. 0.72. What is the ratio of the Amount of goods traded (in US$) of Finland in 2008 to that in 2009?
Your response must be concise. 1.5. What is the ratio of the Amount of goods traded (in US$) of Libya in 2008 to that in 2009?
Provide a succinct answer. 0.98. What is the ratio of the Amount of goods traded (in US$) of Moldova in 2008 to that in 2009?
Provide a short and direct response. 1.52. What is the ratio of the Amount of goods traded (in US$) in Finland in 2008 to that in 2010?
Offer a terse response. 1.32. What is the ratio of the Amount of goods traded (in US$) in Libya in 2008 to that in 2010?
Provide a short and direct response. 0.88. What is the ratio of the Amount of goods traded (in US$) of Moldova in 2008 to that in 2010?
Offer a terse response. 1.3. What is the ratio of the Amount of goods traded (in US$) in Finland in 2008 to that in 2011?
Your response must be concise. 1.08. What is the ratio of the Amount of goods traded (in US$) of Libya in 2008 to that in 2011?
Offer a very short reply. 1.93. What is the ratio of the Amount of goods traded (in US$) of Moldova in 2008 to that in 2011?
Provide a short and direct response. 0.96. What is the ratio of the Amount of goods traded (in US$) in Finland in 2008 to that in 2012?
Your answer should be compact. 1.18. What is the ratio of the Amount of goods traded (in US$) of Libya in 2008 to that in 2012?
Make the answer very short. 0.85. What is the ratio of the Amount of goods traded (in US$) of Moldova in 2008 to that in 2012?
Provide a succinct answer. 0.96. What is the ratio of the Amount of goods traded (in US$) in Finland in 2009 to that in 2010?
Your answer should be compact. 0.88. What is the ratio of the Amount of goods traded (in US$) of Libya in 2009 to that in 2010?
Make the answer very short. 0.9. What is the ratio of the Amount of goods traded (in US$) of Moldova in 2009 to that in 2010?
Provide a succinct answer. 0.86. What is the ratio of the Amount of goods traded (in US$) in Finland in 2009 to that in 2011?
Ensure brevity in your answer.  0.72. What is the ratio of the Amount of goods traded (in US$) in Libya in 2009 to that in 2011?
Ensure brevity in your answer.  1.96. What is the ratio of the Amount of goods traded (in US$) of Moldova in 2009 to that in 2011?
Provide a succinct answer. 0.63. What is the ratio of the Amount of goods traded (in US$) in Finland in 2009 to that in 2012?
Give a very brief answer. 0.79. What is the ratio of the Amount of goods traded (in US$) of Libya in 2009 to that in 2012?
Provide a short and direct response. 0.86. What is the ratio of the Amount of goods traded (in US$) of Moldova in 2009 to that in 2012?
Your answer should be very brief. 0.63. What is the ratio of the Amount of goods traded (in US$) in Finland in 2010 to that in 2011?
Keep it short and to the point. 0.82. What is the ratio of the Amount of goods traded (in US$) of Libya in 2010 to that in 2011?
Make the answer very short. 2.19. What is the ratio of the Amount of goods traded (in US$) in Moldova in 2010 to that in 2011?
Make the answer very short. 0.74. What is the ratio of the Amount of goods traded (in US$) in Finland in 2010 to that in 2012?
Your response must be concise. 0.89. What is the ratio of the Amount of goods traded (in US$) of Libya in 2010 to that in 2012?
Make the answer very short. 0.96. What is the ratio of the Amount of goods traded (in US$) of Moldova in 2010 to that in 2012?
Give a very brief answer. 0.74. What is the ratio of the Amount of goods traded (in US$) of Finland in 2011 to that in 2012?
Ensure brevity in your answer.  1.09. What is the ratio of the Amount of goods traded (in US$) of Libya in 2011 to that in 2012?
Offer a very short reply. 0.44. What is the ratio of the Amount of goods traded (in US$) in Moldova in 2011 to that in 2012?
Your answer should be very brief. 1. What is the difference between the highest and the second highest Amount of goods traded (in US$) of Finland?
Your response must be concise. 6.33e+09. What is the difference between the highest and the second highest Amount of goods traded (in US$) of Libya?
Give a very brief answer. 1.03e+09. What is the difference between the highest and the second highest Amount of goods traded (in US$) of Moldova?
Keep it short and to the point. 2.27e+07. What is the difference between the highest and the lowest Amount of goods traded (in US$) of Finland?
Provide a succinct answer. 3.03e+1. What is the difference between the highest and the lowest Amount of goods traded (in US$) in Libya?
Your answer should be compact. 1.44e+1. What is the difference between the highest and the lowest Amount of goods traded (in US$) in Moldova?
Your answer should be compact. 2.62e+09. 